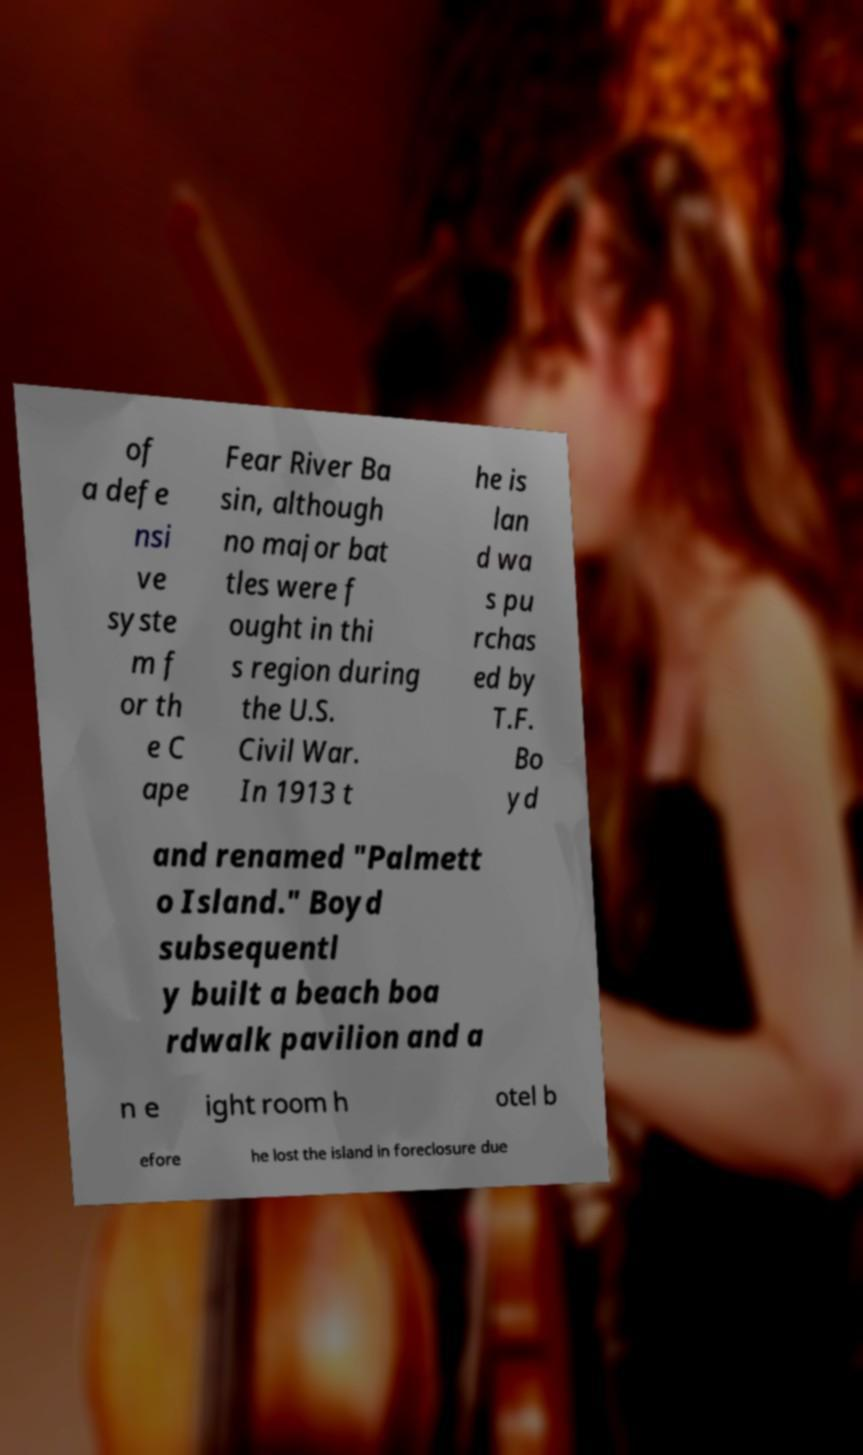For documentation purposes, I need the text within this image transcribed. Could you provide that? of a defe nsi ve syste m f or th e C ape Fear River Ba sin, although no major bat tles were f ought in thi s region during the U.S. Civil War. In 1913 t he is lan d wa s pu rchas ed by T.F. Bo yd and renamed "Palmett o Island." Boyd subsequentl y built a beach boa rdwalk pavilion and a n e ight room h otel b efore he lost the island in foreclosure due 